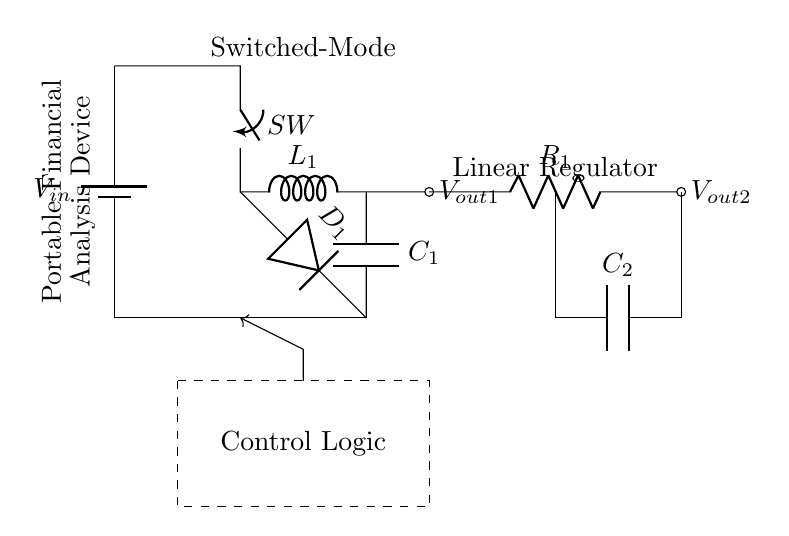What is the input voltage of the circuit? The input voltage is represented as V_in in the circuit diagram, and it indicates the supply voltage for the entire circuit.
Answer: V_in What is the purpose of the switch in the circuit? The switch (SW) is used to control the path of current, enabling or disabling the connection to the inductance and subsequent components of the switched-mode regulator.
Answer: Control current flow How many output voltages does this circuit provide? The circuit has two output voltages: V_out1 from the switched-mode regulator and V_out2 from the linear regulator.
Answer: Two What type of regulator is depicted on the left side of the circuit? The left side of the circuit contains a switched-mode regulator, characterized by its use of an inductor and a diode for voltage conversion efficiency.
Answer: Switched-mode regulator What component is used to smooth the output voltage of the linear regulator? A capacitor (C2) is used to smooth the output voltage at the output of the linear regulator, reducing voltage ripple and stabilizing the voltage.
Answer: Capacitor Explain the role of the control logic in the circuit. The control logic regulates the functioning of the circuit by ensuring proper switch operation and adjusts the output based on voltage feedback to maintain stable output voltages.
Answer: Regulates output 